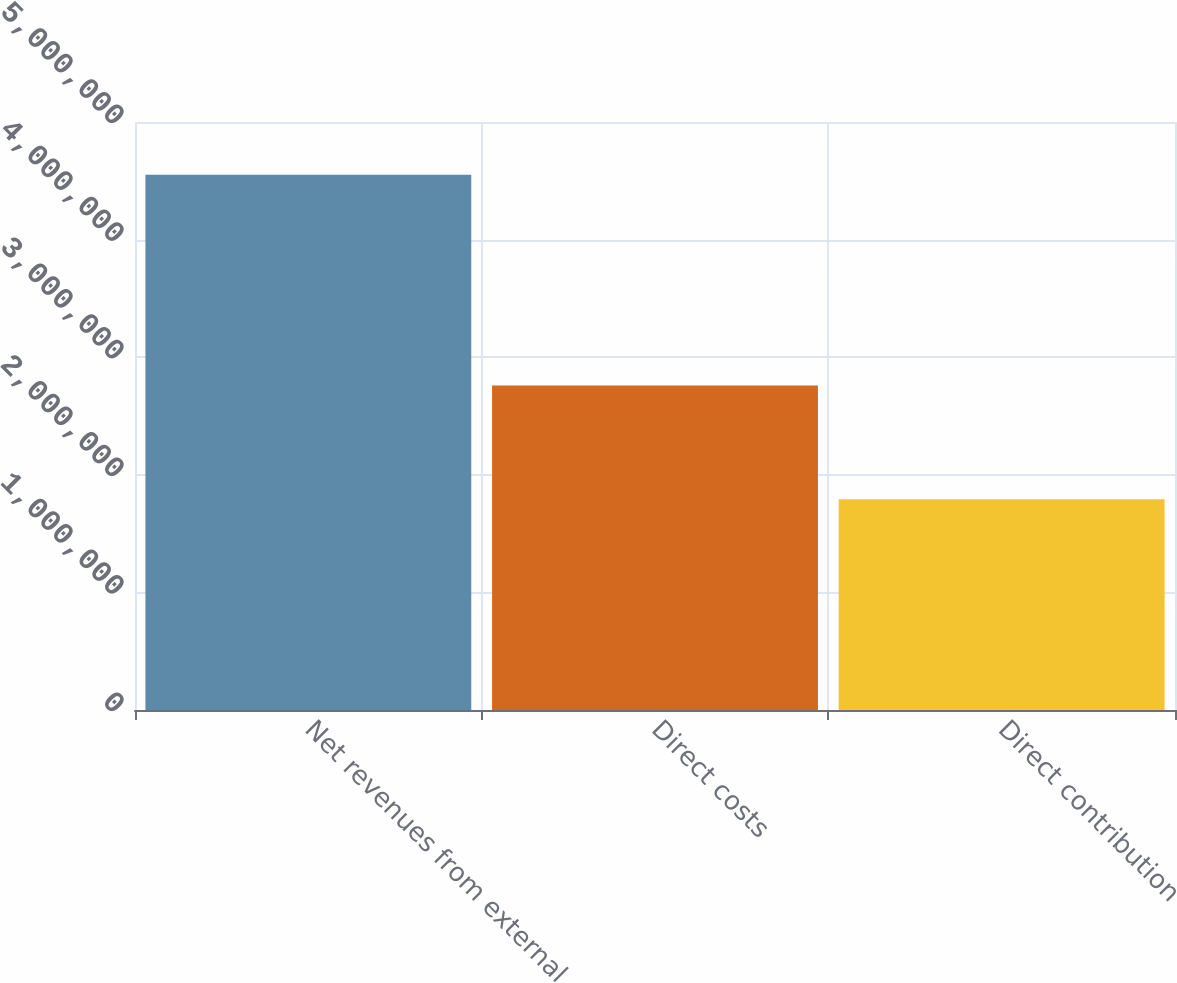Convert chart. <chart><loc_0><loc_0><loc_500><loc_500><bar_chart><fcel>Net revenues from external<fcel>Direct costs<fcel>Direct contribution<nl><fcel>4.5524e+06<fcel>2.75965e+06<fcel>1.79275e+06<nl></chart> 